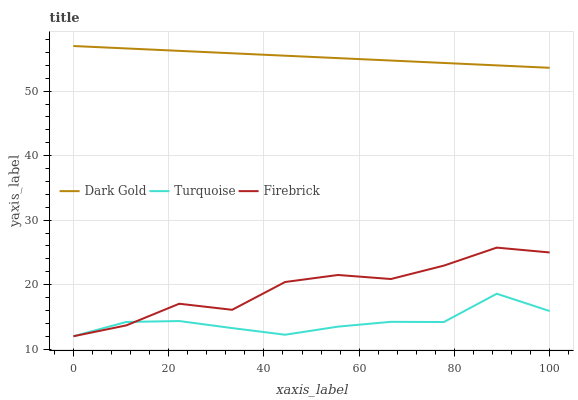Does Turquoise have the minimum area under the curve?
Answer yes or no. Yes. Does Dark Gold have the maximum area under the curve?
Answer yes or no. Yes. Does Firebrick have the minimum area under the curve?
Answer yes or no. No. Does Firebrick have the maximum area under the curve?
Answer yes or no. No. Is Dark Gold the smoothest?
Answer yes or no. Yes. Is Firebrick the roughest?
Answer yes or no. Yes. Is Firebrick the smoothest?
Answer yes or no. No. Is Dark Gold the roughest?
Answer yes or no. No. Does Turquoise have the lowest value?
Answer yes or no. Yes. Does Dark Gold have the lowest value?
Answer yes or no. No. Does Dark Gold have the highest value?
Answer yes or no. Yes. Does Firebrick have the highest value?
Answer yes or no. No. Is Turquoise less than Dark Gold?
Answer yes or no. Yes. Is Dark Gold greater than Turquoise?
Answer yes or no. Yes. Does Firebrick intersect Turquoise?
Answer yes or no. Yes. Is Firebrick less than Turquoise?
Answer yes or no. No. Is Firebrick greater than Turquoise?
Answer yes or no. No. Does Turquoise intersect Dark Gold?
Answer yes or no. No. 